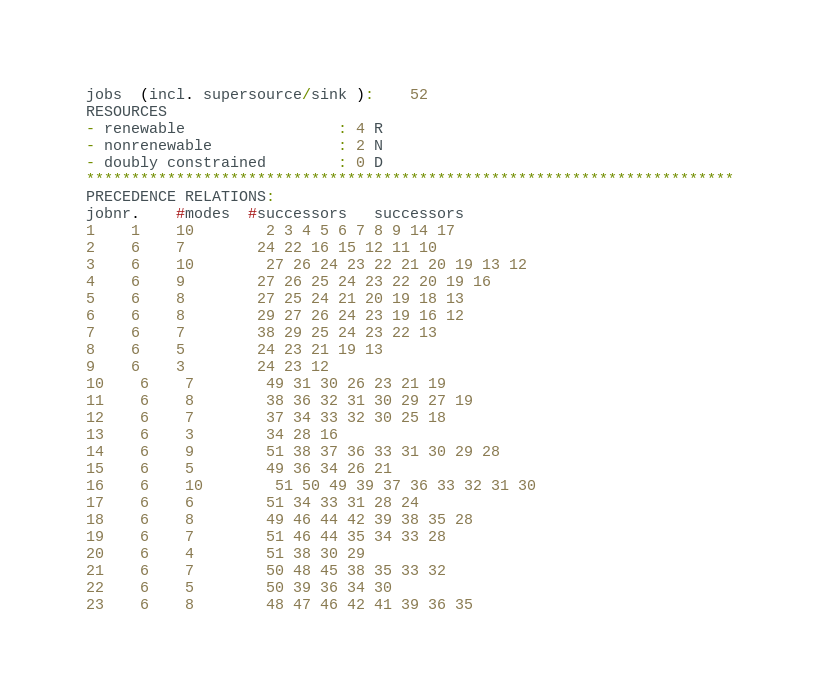Convert code to text. <code><loc_0><loc_0><loc_500><loc_500><_ObjectiveC_>jobs  (incl. supersource/sink ):	52
RESOURCES
- renewable                 : 4 R
- nonrenewable              : 2 N
- doubly constrained        : 0 D
************************************************************************
PRECEDENCE RELATIONS:
jobnr.    #modes  #successors   successors
1	1	10		2 3 4 5 6 7 8 9 14 17 
2	6	7		24 22 16 15 12 11 10 
3	6	10		27 26 24 23 22 21 20 19 13 12 
4	6	9		27 26 25 24 23 22 20 19 16 
5	6	8		27 25 24 21 20 19 18 13 
6	6	8		29 27 26 24 23 19 16 12 
7	6	7		38 29 25 24 23 22 13 
8	6	5		24 23 21 19 13 
9	6	3		24 23 12 
10	6	7		49 31 30 26 23 21 19 
11	6	8		38 36 32 31 30 29 27 19 
12	6	7		37 34 33 32 30 25 18 
13	6	3		34 28 16 
14	6	9		51 38 37 36 33 31 30 29 28 
15	6	5		49 36 34 26 21 
16	6	10		51 50 49 39 37 36 33 32 31 30 
17	6	6		51 34 33 31 28 24 
18	6	8		49 46 44 42 39 38 35 28 
19	6	7		51 46 44 35 34 33 28 
20	6	4		51 38 30 29 
21	6	7		50 48 45 38 35 33 32 
22	6	5		50 39 36 34 30 
23	6	8		48 47 46 42 41 39 36 35 </code> 